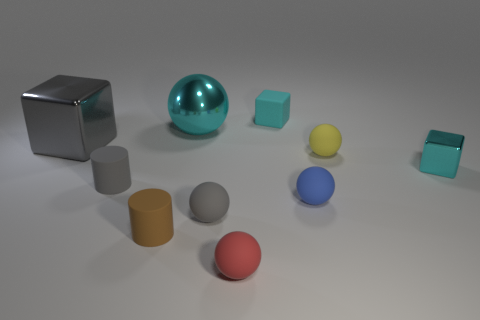Subtract all green balls. How many cyan blocks are left? 2 Subtract all tiny yellow rubber spheres. How many spheres are left? 4 Subtract all red balls. How many balls are left? 4 Subtract 1 blocks. How many blocks are left? 2 Subtract all cylinders. How many objects are left? 8 Subtract all yellow balls. Subtract all red cubes. How many balls are left? 4 Add 9 large gray things. How many large gray things are left? 10 Add 3 small yellow objects. How many small yellow objects exist? 4 Subtract 1 cyan spheres. How many objects are left? 9 Subtract all rubber cylinders. Subtract all purple metallic objects. How many objects are left? 8 